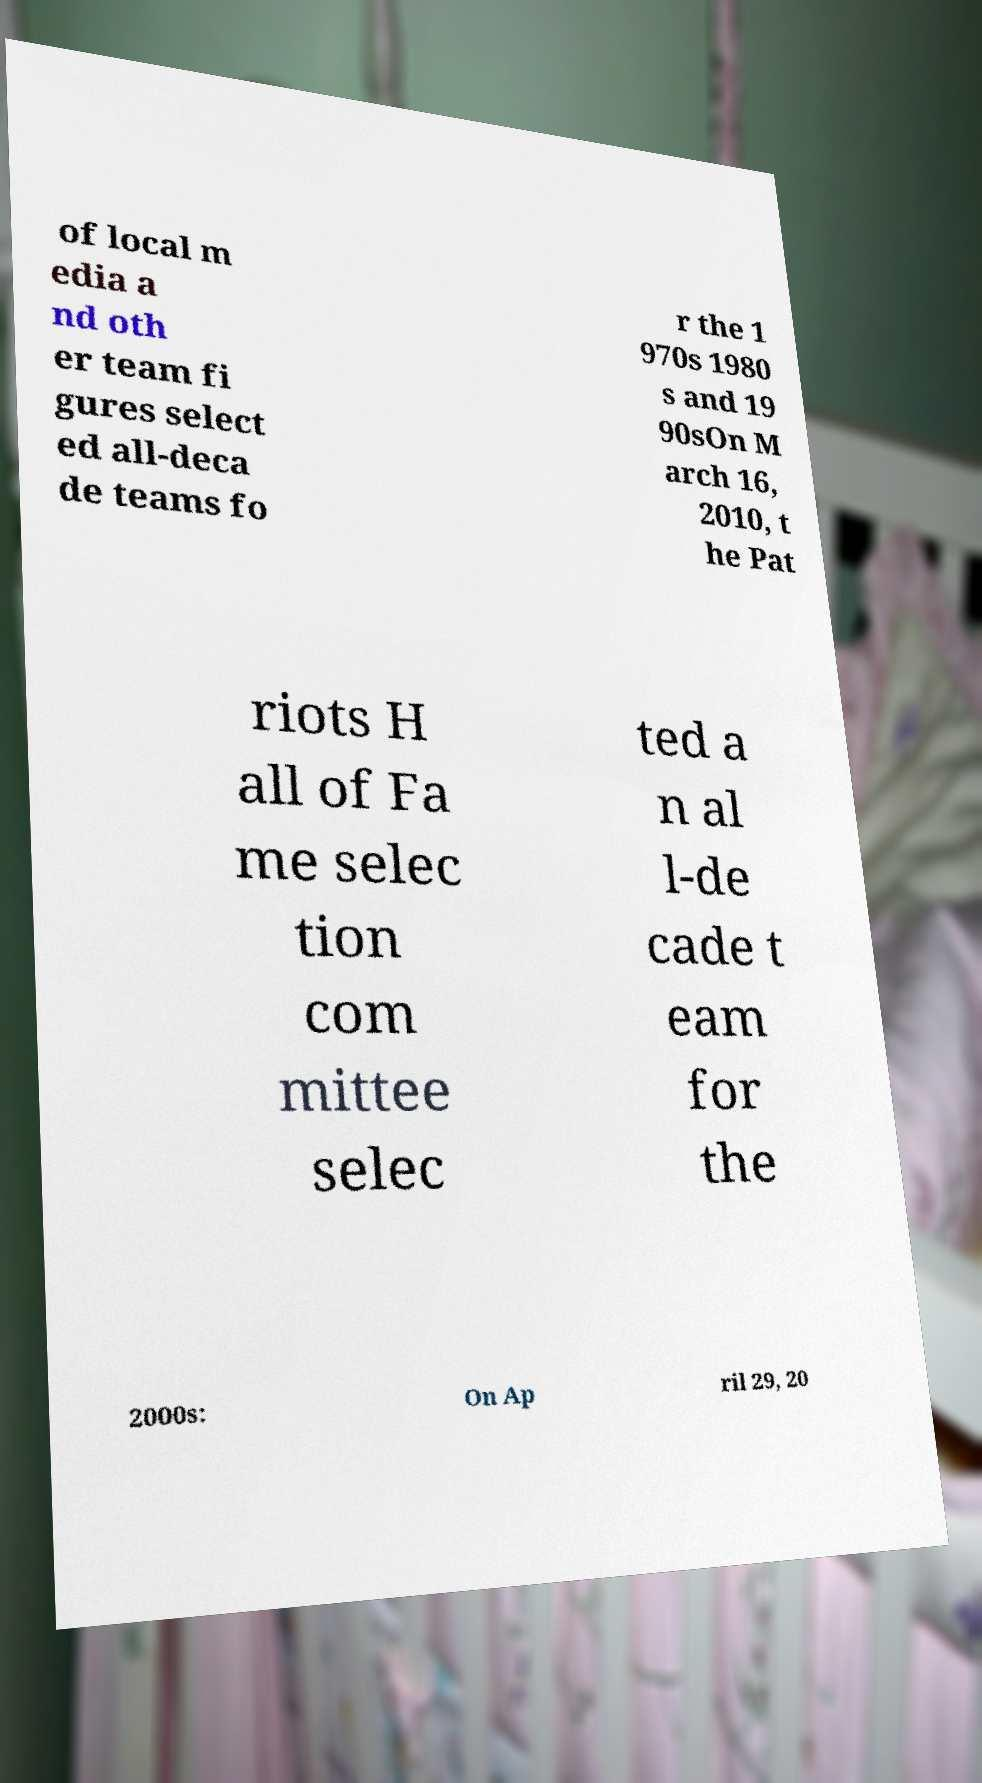Could you assist in decoding the text presented in this image and type it out clearly? of local m edia a nd oth er team fi gures select ed all-deca de teams fo r the 1 970s 1980 s and 19 90sOn M arch 16, 2010, t he Pat riots H all of Fa me selec tion com mittee selec ted a n al l-de cade t eam for the 2000s: On Ap ril 29, 20 